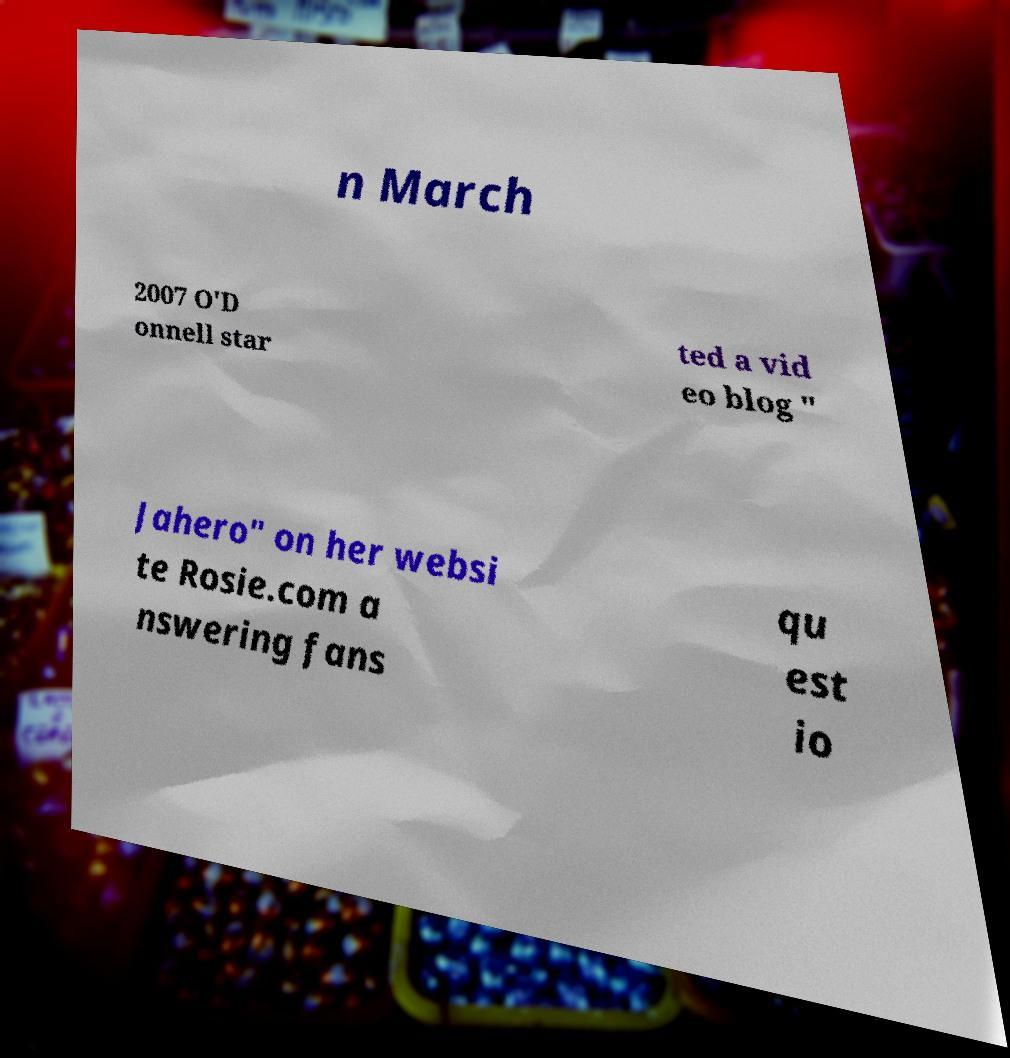Could you extract and type out the text from this image? n March 2007 O'D onnell star ted a vid eo blog " Jahero" on her websi te Rosie.com a nswering fans qu est io 